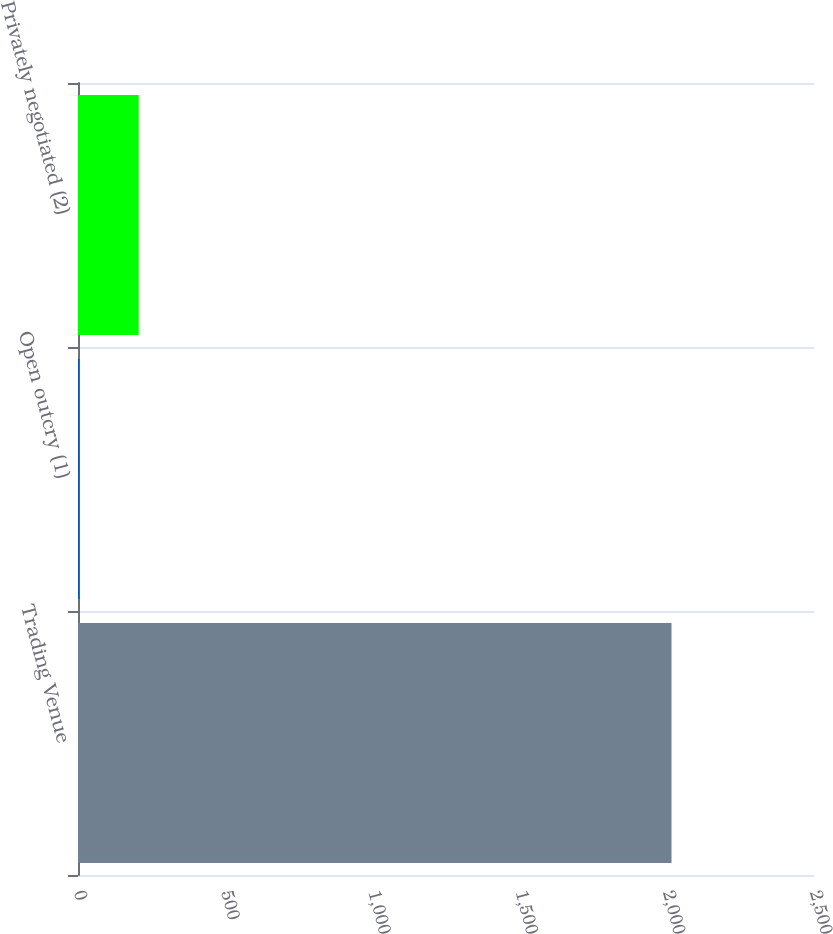Convert chart to OTSL. <chart><loc_0><loc_0><loc_500><loc_500><bar_chart><fcel>Trading Venue<fcel>Open outcry (1)<fcel>Privately negotiated (2)<nl><fcel>2016<fcel>5<fcel>206.1<nl></chart> 